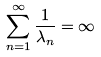Convert formula to latex. <formula><loc_0><loc_0><loc_500><loc_500>\sum _ { n = 1 } ^ { \infty } \frac { 1 } { \lambda _ { n } } = \infty</formula> 